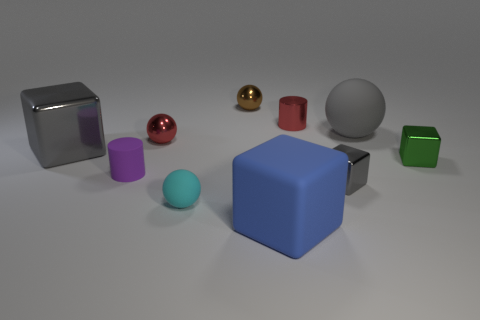There is a small brown metal thing; does it have the same shape as the tiny metal thing that is on the right side of the gray matte object?
Offer a terse response. No. What is the size of the gray object that is the same shape as the cyan rubber object?
Offer a terse response. Large. There is a big rubber ball; is it the same color as the small sphere that is in front of the tiny gray metal object?
Your answer should be very brief. No. What number of other objects are the same size as the blue block?
Offer a terse response. 2. There is a large gray object behind the big block that is on the left side of the tiny shiny ball that is behind the big gray matte ball; what shape is it?
Make the answer very short. Sphere. There is a gray matte ball; is its size the same as the metal sphere behind the small red metal sphere?
Give a very brief answer. No. What is the color of the thing that is both on the left side of the matte cube and behind the large sphere?
Provide a succinct answer. Brown. What number of other things are the same shape as the green thing?
Make the answer very short. 3. Is the color of the rubber ball that is on the right side of the blue matte thing the same as the rubber ball in front of the tiny green metallic object?
Make the answer very short. No. There is a shiny block that is to the right of the large matte sphere; is its size the same as the rubber thing that is behind the green thing?
Offer a very short reply. No. 